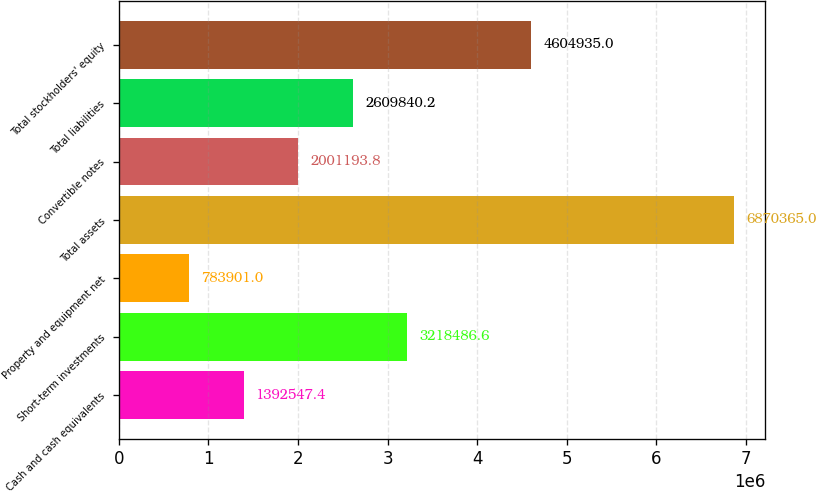<chart> <loc_0><loc_0><loc_500><loc_500><bar_chart><fcel>Cash and cash equivalents<fcel>Short-term investments<fcel>Property and equipment net<fcel>Total assets<fcel>Convertible notes<fcel>Total liabilities<fcel>Total stockholders' equity<nl><fcel>1.39255e+06<fcel>3.21849e+06<fcel>783901<fcel>6.87036e+06<fcel>2.00119e+06<fcel>2.60984e+06<fcel>4.60494e+06<nl></chart> 